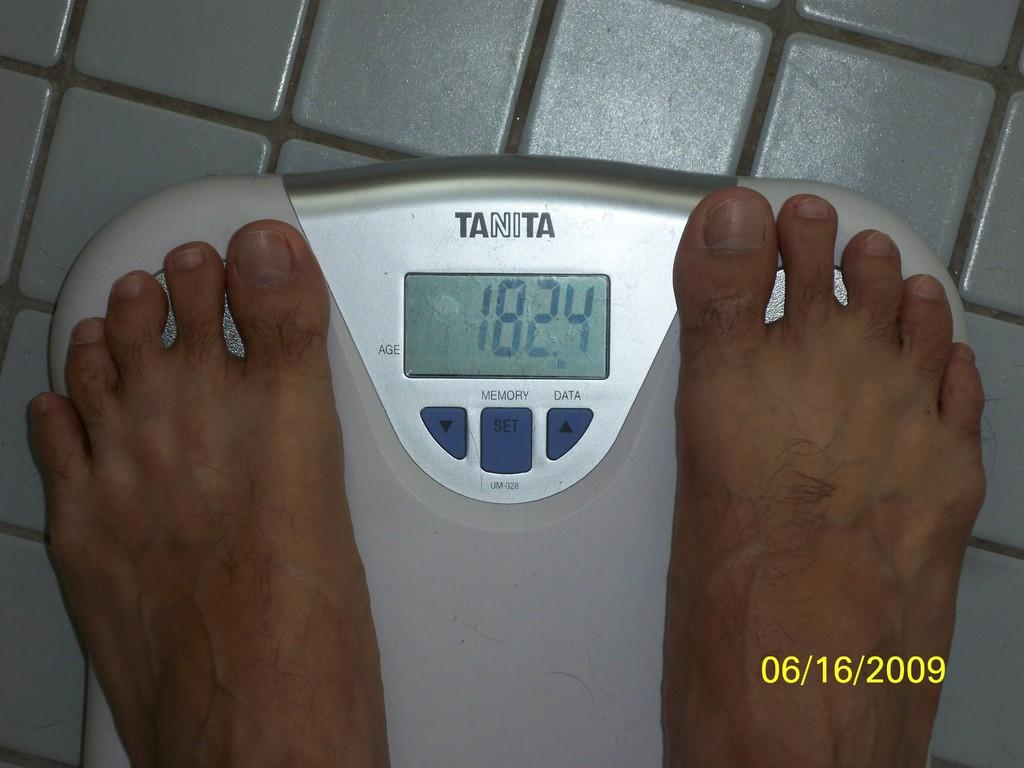<image>
Offer a succinct explanation of the picture presented. A person stands on a bathroom scale, which reads 182.4. 